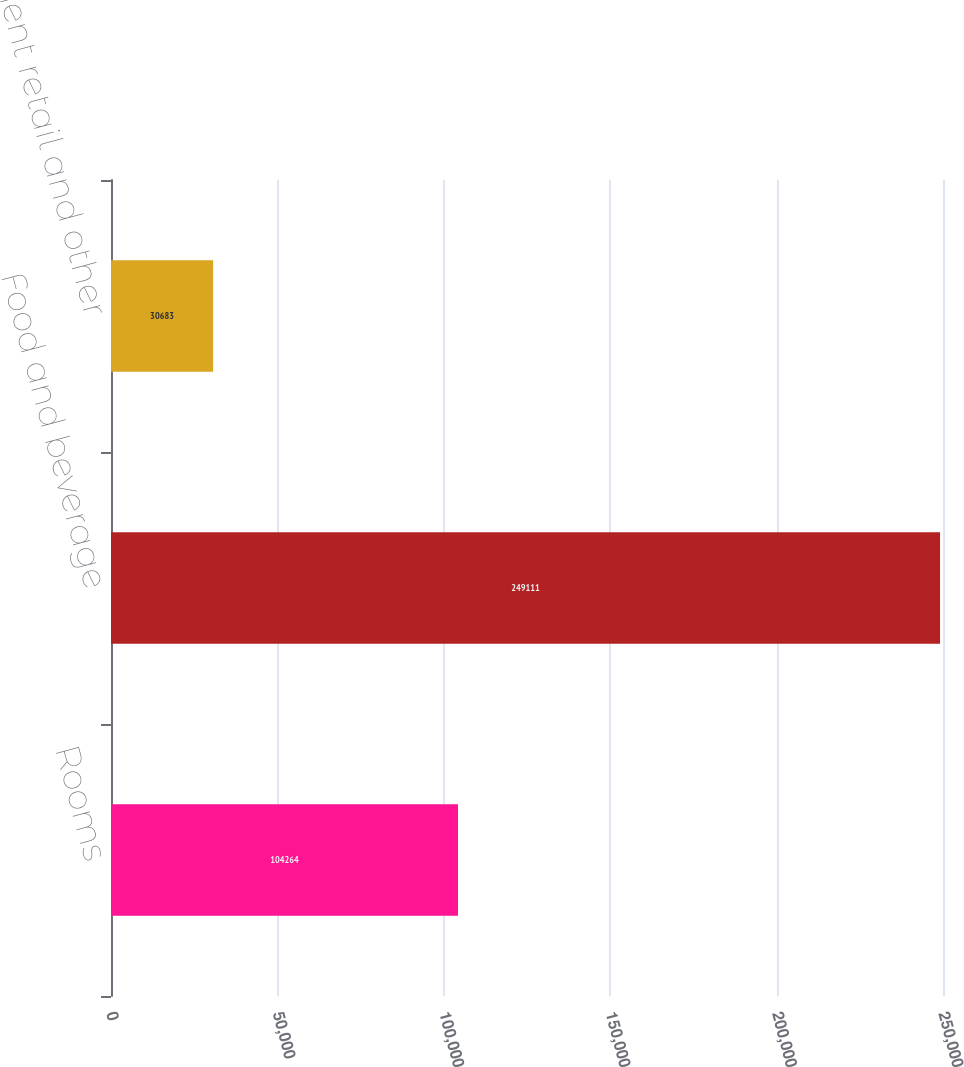Convert chart. <chart><loc_0><loc_0><loc_500><loc_500><bar_chart><fcel>Rooms<fcel>Food and beverage<fcel>Entertainment retail and other<nl><fcel>104264<fcel>249111<fcel>30683<nl></chart> 